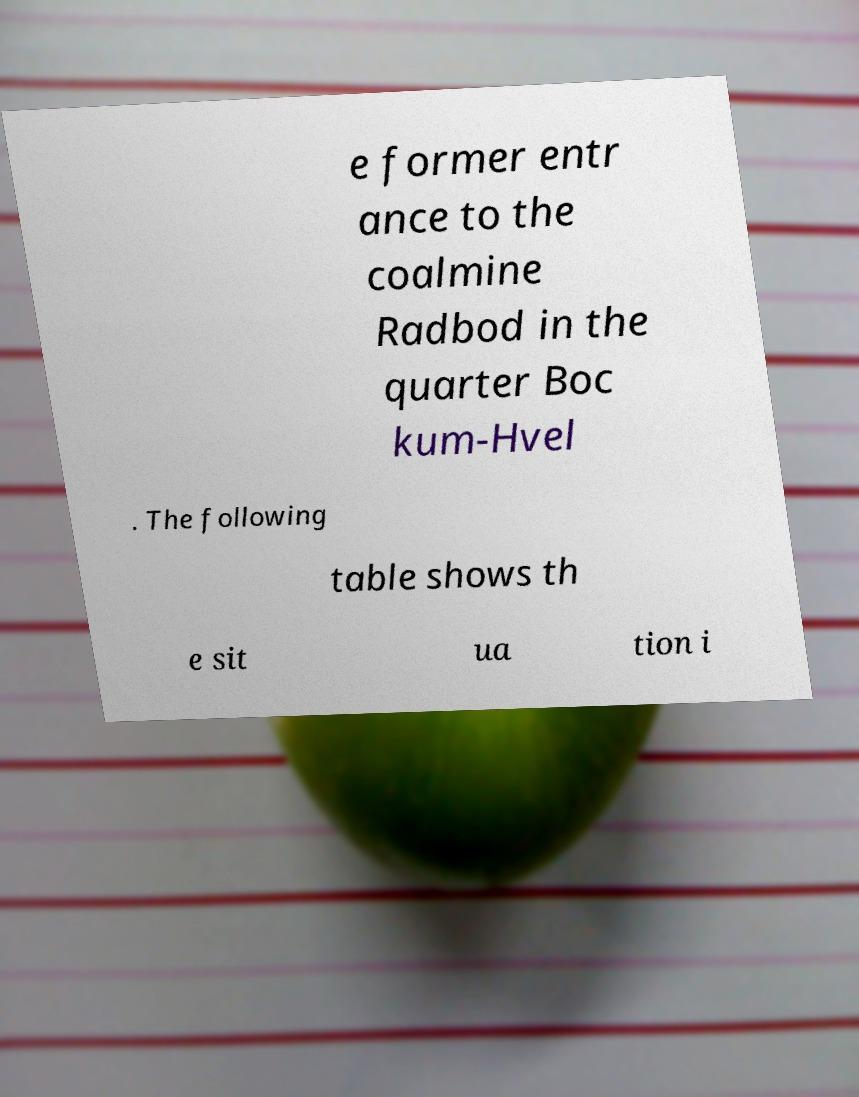Could you extract and type out the text from this image? e former entr ance to the coalmine Radbod in the quarter Boc kum-Hvel . The following table shows th e sit ua tion i 